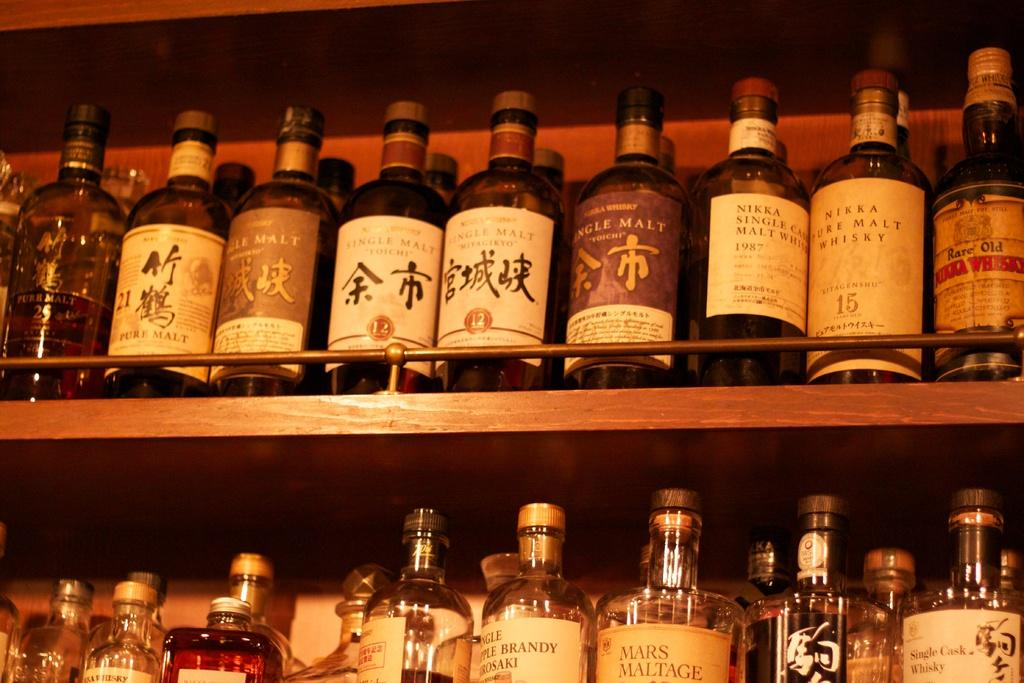Provide a one-sentence caption for the provided image. the word malt is on a purple bottle. 